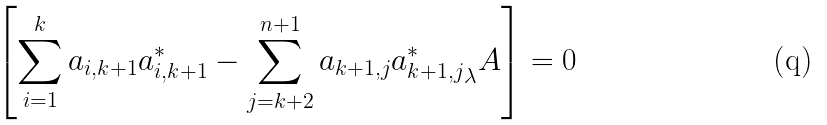<formula> <loc_0><loc_0><loc_500><loc_500>\left [ \sum _ { i = 1 } ^ { k } a _ { i , k + 1 } a _ { i , k + 1 } ^ { * } - \sum _ { j = k + 2 } ^ { n + 1 } a _ { k + 1 , j } { a _ { k + 1 , j } ^ { * } } _ { \lambda } A \right ] = 0</formula> 